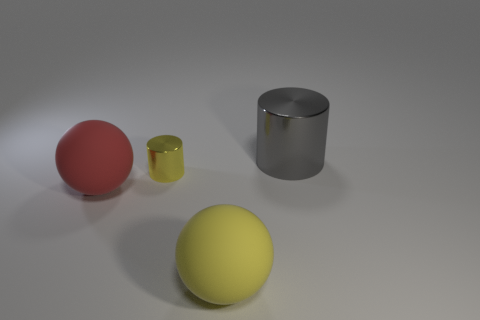Is the color of the metal cylinder in front of the large cylinder the same as the large metal cylinder?
Give a very brief answer. No. What number of other things are the same shape as the big red object?
Your answer should be very brief. 1. What number of things are either gray shiny cylinders behind the small yellow metallic thing or things that are on the right side of the red rubber thing?
Keep it short and to the point. 3. How many purple objects are either rubber things or small metal balls?
Give a very brief answer. 0. What material is the large thing that is behind the big yellow rubber object and in front of the large shiny cylinder?
Your answer should be very brief. Rubber. Is the tiny yellow cylinder made of the same material as the large red sphere?
Your response must be concise. No. How many cyan cylinders have the same size as the gray metal cylinder?
Keep it short and to the point. 0. Are there the same number of red objects that are behind the gray metal cylinder and small yellow metal objects?
Your answer should be very brief. No. How many cylinders are right of the large yellow matte sphere and left of the big gray cylinder?
Give a very brief answer. 0. Do the yellow thing behind the large yellow object and the gray object have the same shape?
Your response must be concise. Yes. 